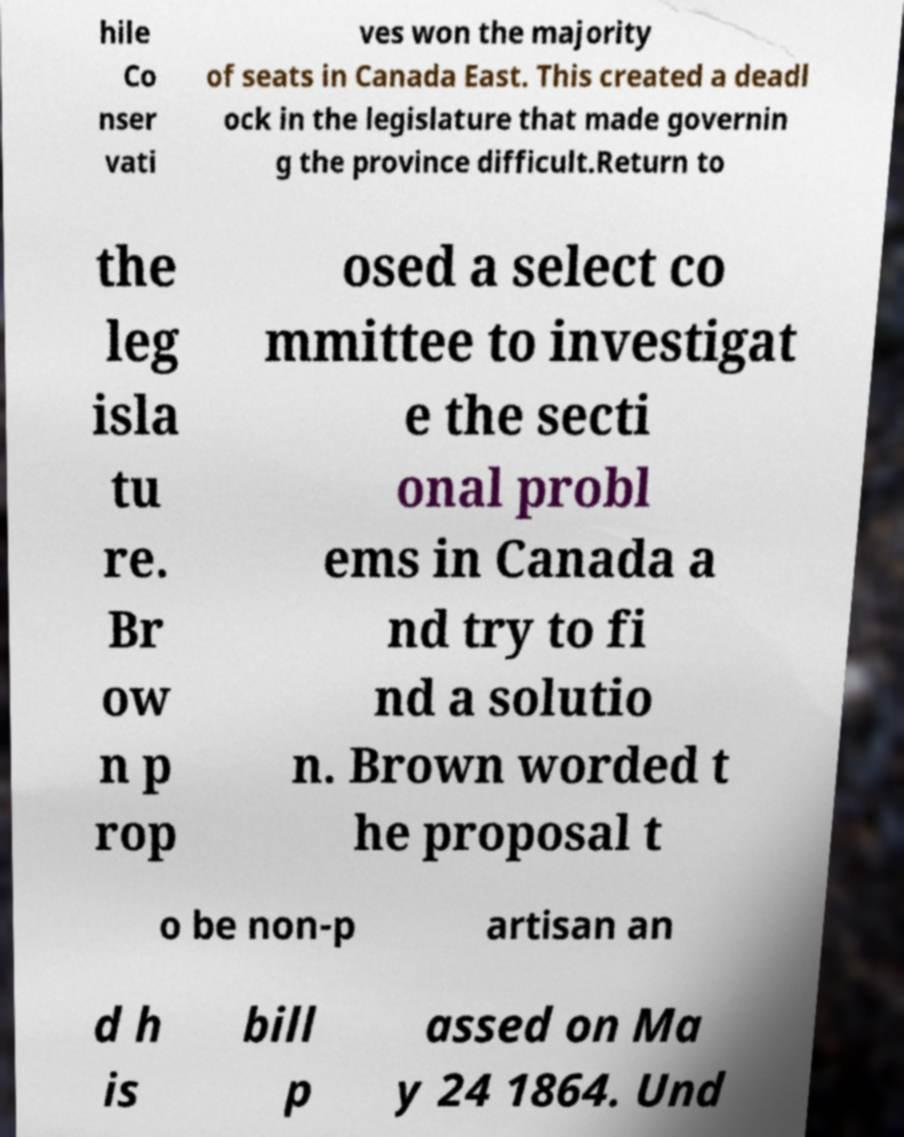Can you accurately transcribe the text from the provided image for me? hile Co nser vati ves won the majority of seats in Canada East. This created a deadl ock in the legislature that made governin g the province difficult.Return to the leg isla tu re. Br ow n p rop osed a select co mmittee to investigat e the secti onal probl ems in Canada a nd try to fi nd a solutio n. Brown worded t he proposal t o be non-p artisan an d h is bill p assed on Ma y 24 1864. Und 